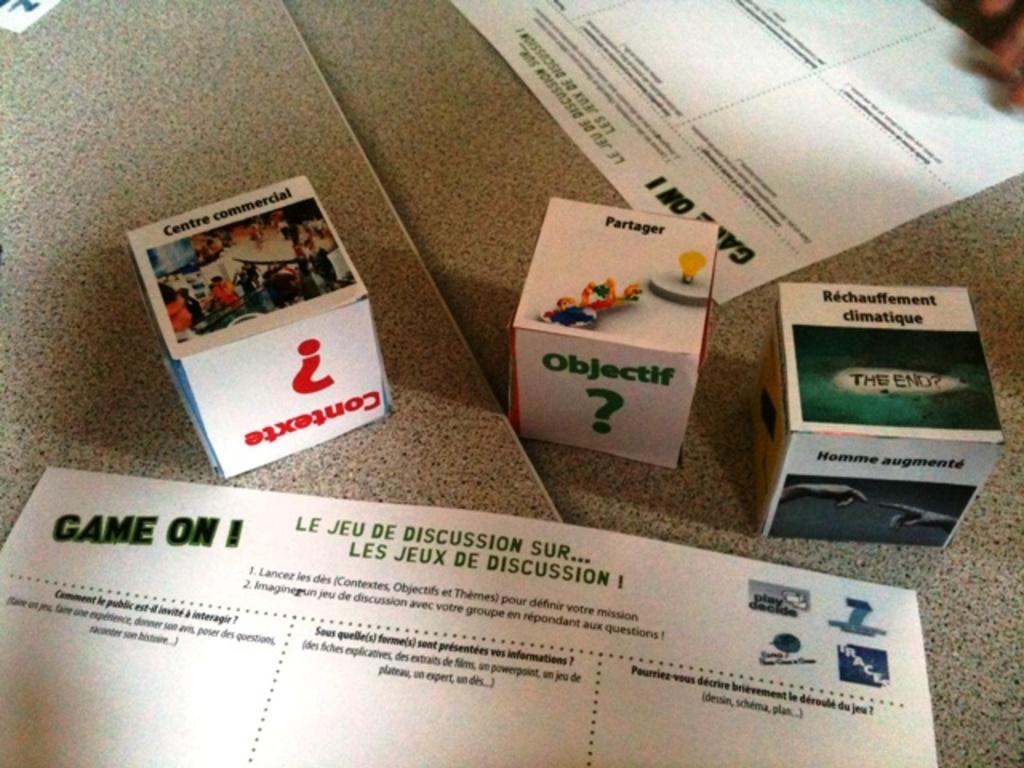<image>
Render a clear and concise summary of the photo. boxes on the ground for the game Game On! read Objectif 